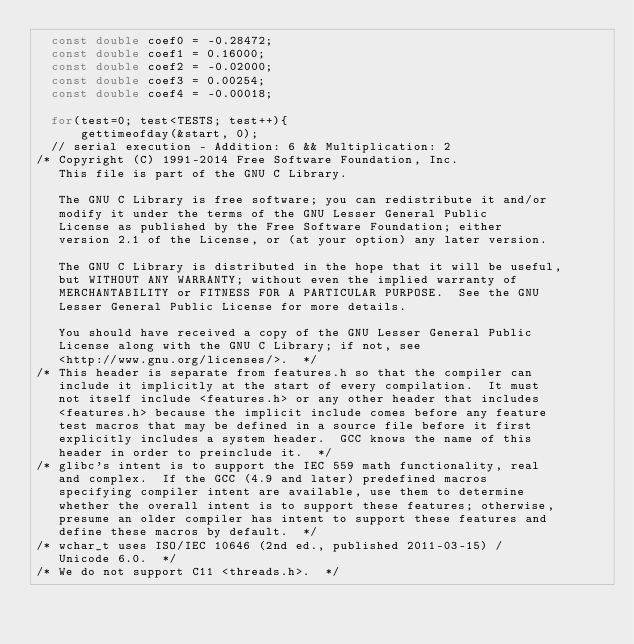Convert code to text. <code><loc_0><loc_0><loc_500><loc_500><_C_>  const double coef0 = -0.28472;
  const double coef1 = 0.16000;
  const double coef2 = -0.02000;
  const double coef3 = 0.00254;
  const double coef4 = -0.00018;

  for(test=0; test<TESTS; test++){
      gettimeofday(&start, 0);
  // serial execution - Addition: 6 && Multiplication: 2
/* Copyright (C) 1991-2014 Free Software Foundation, Inc.
   This file is part of the GNU C Library.

   The GNU C Library is free software; you can redistribute it and/or
   modify it under the terms of the GNU Lesser General Public
   License as published by the Free Software Foundation; either
   version 2.1 of the License, or (at your option) any later version.

   The GNU C Library is distributed in the hope that it will be useful,
   but WITHOUT ANY WARRANTY; without even the implied warranty of
   MERCHANTABILITY or FITNESS FOR A PARTICULAR PURPOSE.  See the GNU
   Lesser General Public License for more details.

   You should have received a copy of the GNU Lesser General Public
   License along with the GNU C Library; if not, see
   <http://www.gnu.org/licenses/>.  */
/* This header is separate from features.h so that the compiler can
   include it implicitly at the start of every compilation.  It must
   not itself include <features.h> or any other header that includes
   <features.h> because the implicit include comes before any feature
   test macros that may be defined in a source file before it first
   explicitly includes a system header.  GCC knows the name of this
   header in order to preinclude it.  */
/* glibc's intent is to support the IEC 559 math functionality, real
   and complex.  If the GCC (4.9 and later) predefined macros
   specifying compiler intent are available, use them to determine
   whether the overall intent is to support these features; otherwise,
   presume an older compiler has intent to support these features and
   define these macros by default.  */
/* wchar_t uses ISO/IEC 10646 (2nd ed., published 2011-03-15) /
   Unicode 6.0.  */
/* We do not support C11 <threads.h>.  */</code> 